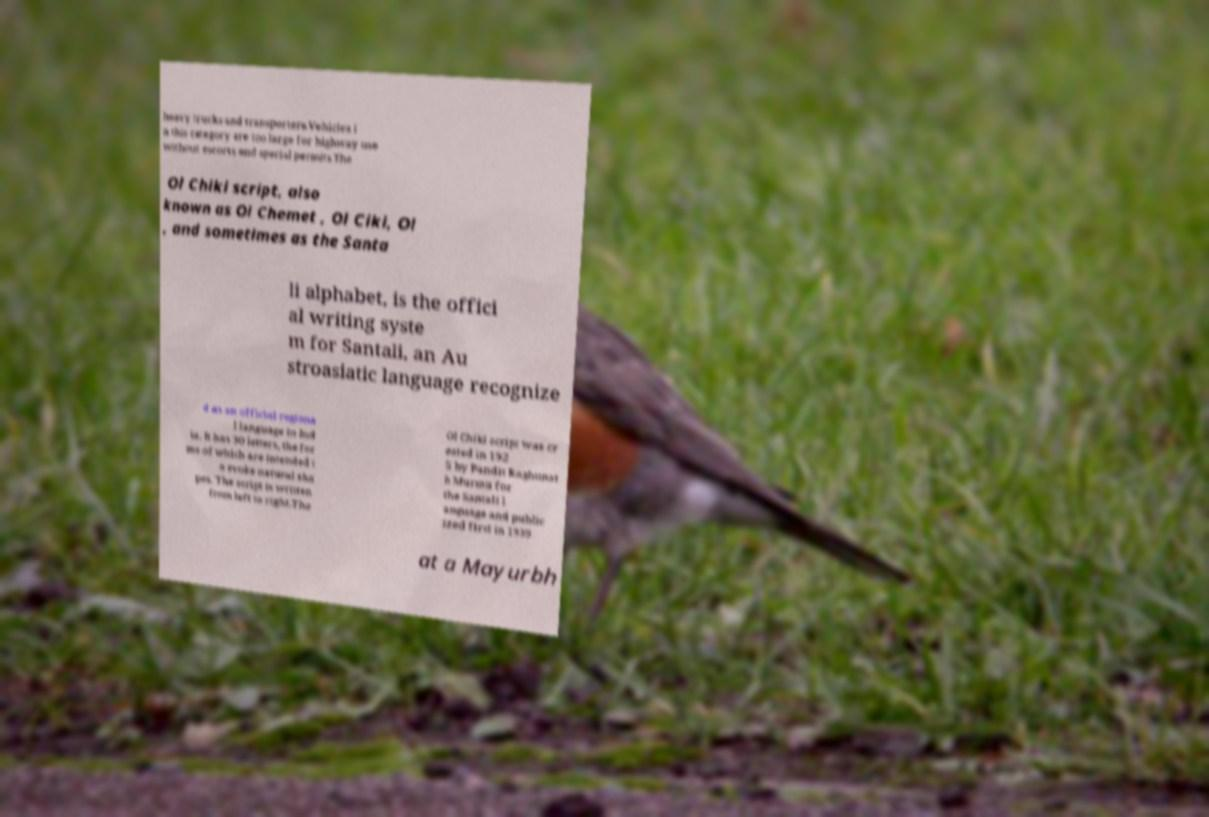Could you extract and type out the text from this image? heavy trucks and transporters.Vehicles i n this category are too large for highway use without escorts and special permits.The Ol Chiki script, also known as Ol Chemet , Ol Ciki, Ol , and sometimes as the Santa li alphabet, is the offici al writing syste m for Santali, an Au stroasiatic language recognize d as an official regiona l language in Ind ia. It has 30 letters, the for ms of which are intended t o evoke natural sha pes. The script is written from left to right.The Ol Chiki script was cr eated in 192 5 by Pandit Raghunat h Murmu for the Santali l anguage and public ized first in 1939 at a Mayurbh 